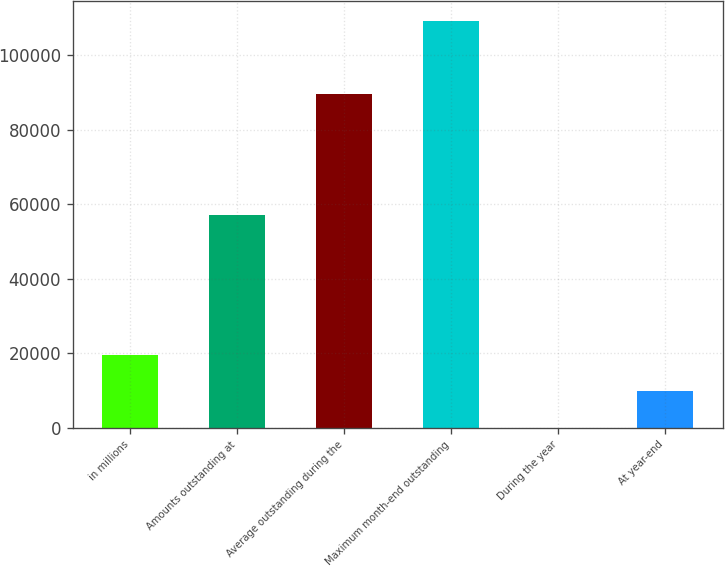<chart> <loc_0><loc_0><loc_500><loc_500><bar_chart><fcel>in millions<fcel>Amounts outstanding at<fcel>Average outstanding during the<fcel>Maximum month-end outstanding<fcel>During the year<fcel>At year-end<nl><fcel>19493.5<fcel>57020<fcel>89662<fcel>109155<fcel>0.37<fcel>9746.93<nl></chart> 